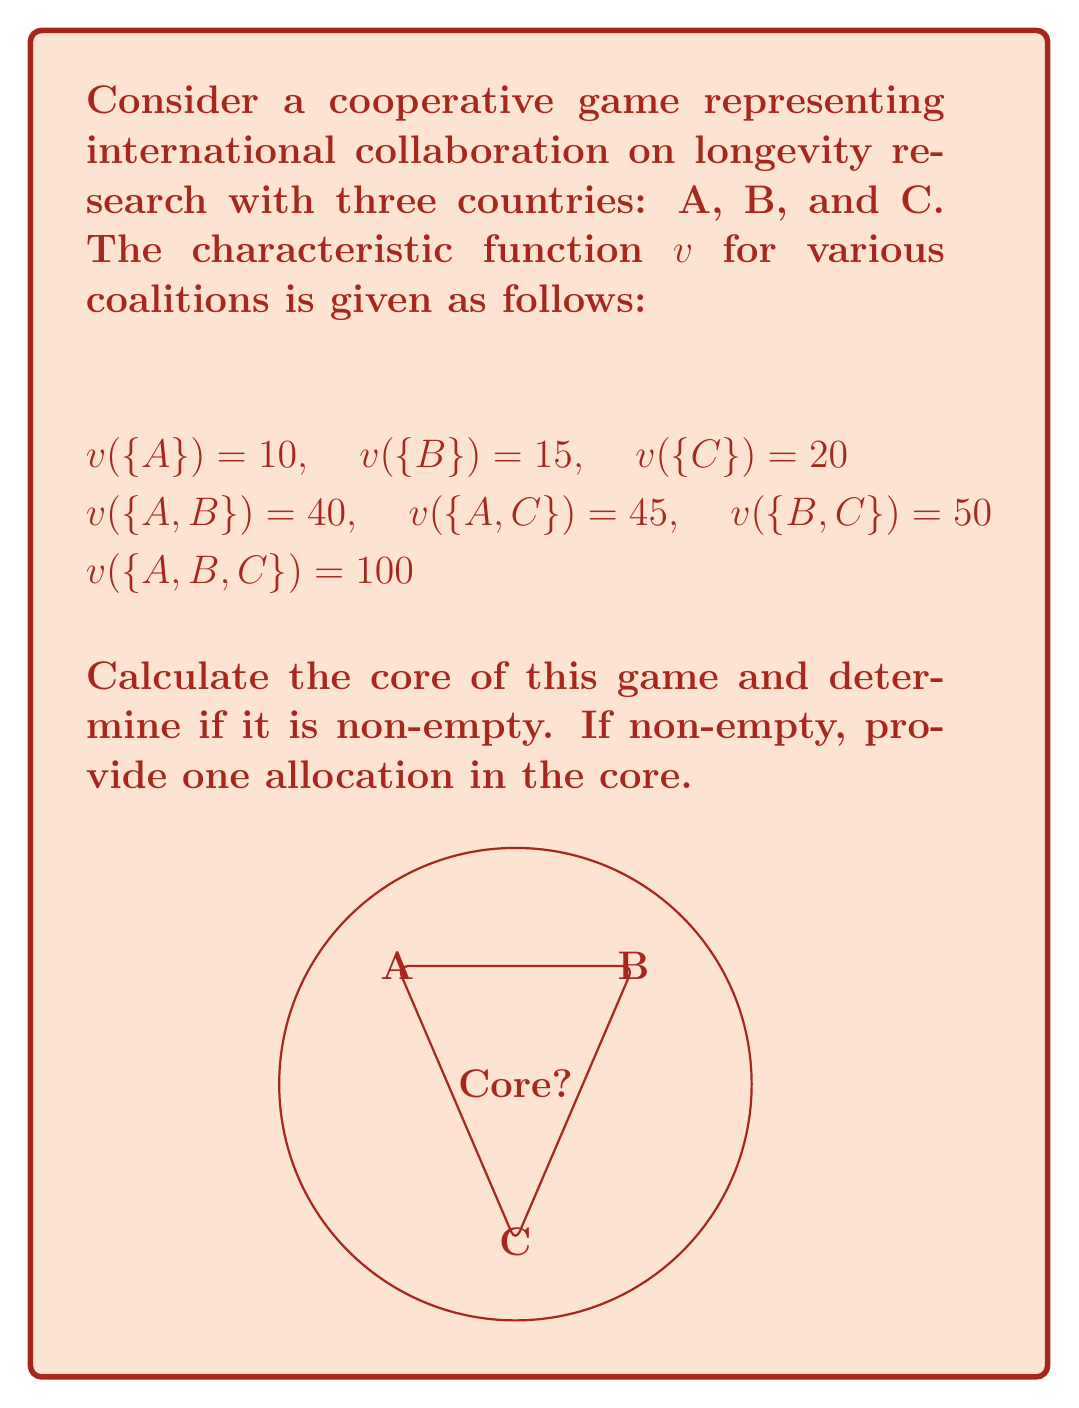Can you solve this math problem? To find the core of this cooperative game, we need to check if there exists an allocation $(x_A, x_B, x_C)$ that satisfies the following conditions:

1. Efficiency: $x_A + x_B + x_C = v(\{A,B,C\}) = 100$
2. Individual rationality: $x_A \geq 10$, $x_B \geq 15$, $x_C \geq 20$
3. Coalitional rationality: 
   $x_A + x_B \geq 40$
   $x_A + x_C \geq 45$
   $x_B + x_C \geq 50$

Let's solve this step by step:

Step 1: Set up the linear programming problem
Maximize: $z = x_A + x_B + x_C$
Subject to:
$x_A + x_B + x_C = 100$
$x_A \geq 10$
$x_B \geq 15$
$x_C \geq 20$
$x_A + x_B \geq 40$
$x_A + x_C \geq 45$
$x_B + x_C \geq 50$

Step 2: Solve the linear programming problem
We can solve this using the simplex method or other LP solving techniques. However, we can also find a feasible solution by inspection:

Let $x_A = 30$, $x_B = 35$, $x_C = 35$

This allocation satisfies all constraints:
$30 + 35 + 35 = 100$
$30 \geq 10$, $35 \geq 15$, $35 \geq 20$
$30 + 35 = 65 \geq 40$
$30 + 35 = 65 \geq 45$
$35 + 35 = 70 \geq 50$

Step 3: Determine if the core is non-empty
Since we found a feasible solution that satisfies all constraints, the core is non-empty.

Step 4: Provide an allocation in the core
The allocation $(x_A, x_B, x_C) = (30, 35, 35)$ is in the core of the game.
Answer: Core is non-empty; $(30, 35, 35)$ is in the core. 